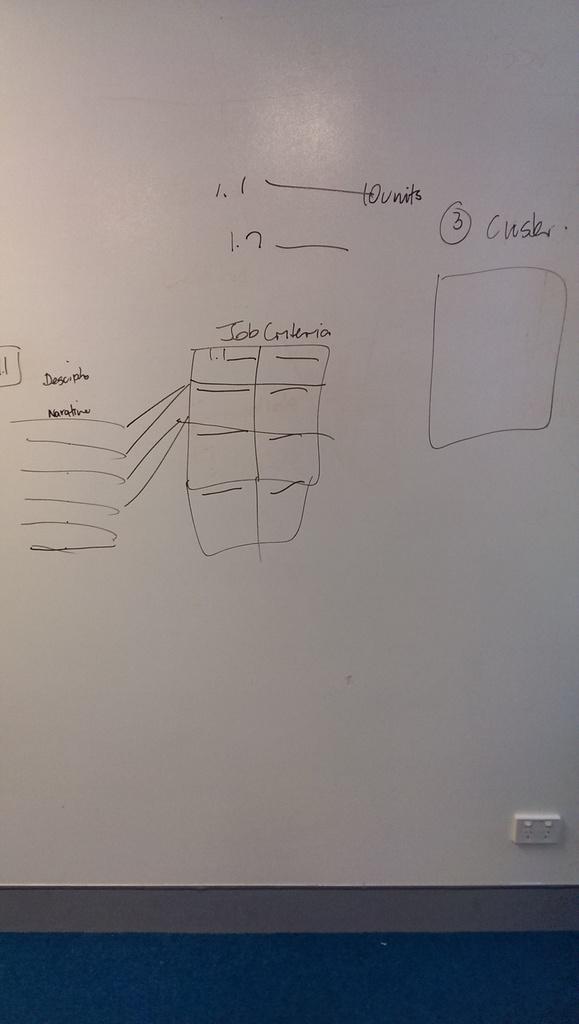What criteria is mentioned on the board?
Offer a very short reply. Job. What number is on the board?
Offer a terse response. 3. 